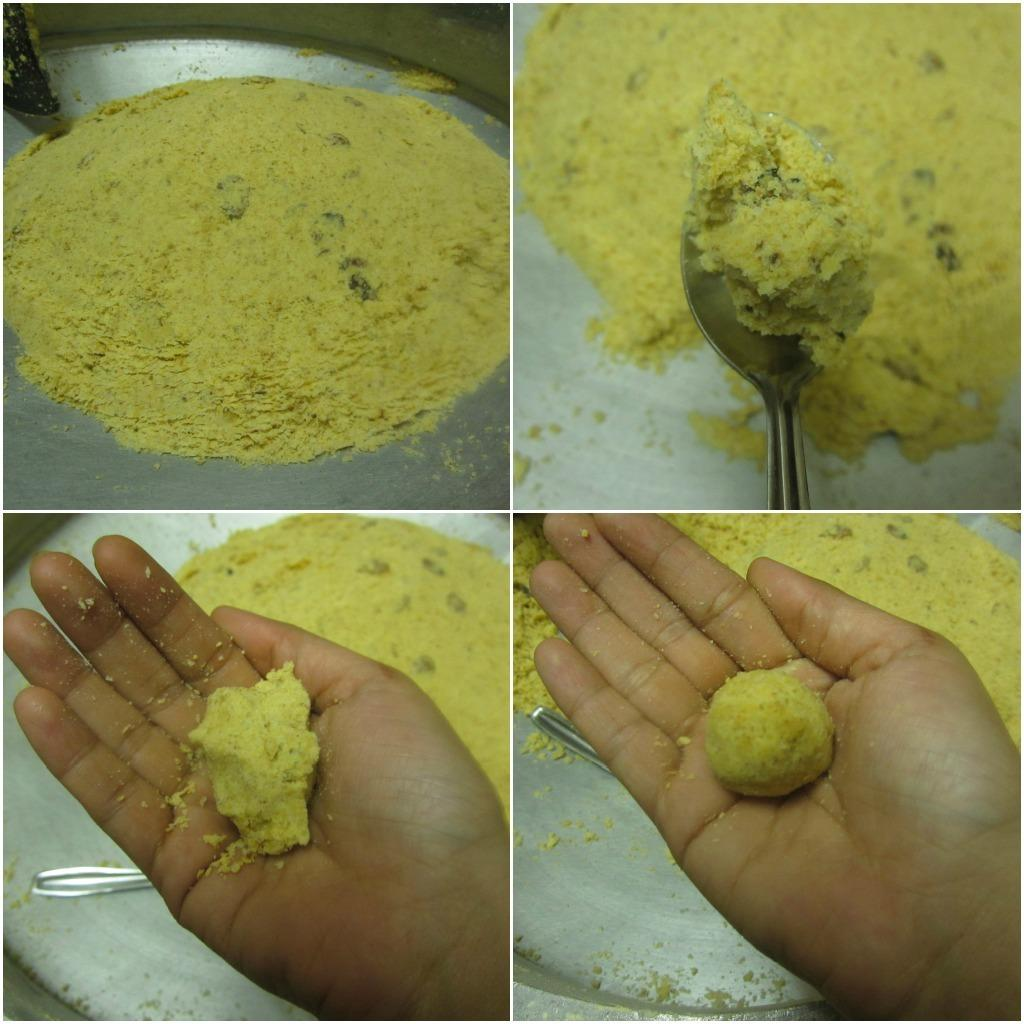What type of institution is depicted in the image? There is a college in the image. Can you describe any specific features of the college? Unfortunately, the provided facts do not include any specific details about the college. What might be happening at the college in the image? Without additional information, it is impossible to determine what might be happening at the college in the image. Reasoning: Let's think step by step by step in order to produce the conversation. We start by identifying the main subject in the image, which is the college. However, since there is only one fact provided, we cannot describe any specific features or activities related to the college. We formulate questions that focus on the general information about the college, acknowledging the lack of detail in the provided facts. We avoid making assumptions or guesses about the image and ensure that the language is simple and clear. Absurd Question/Answer: What type of pleasure can be seen being derived from the drawer in the image? There is no drawer present in the image, and therefore no pleasure can be derived from it. 